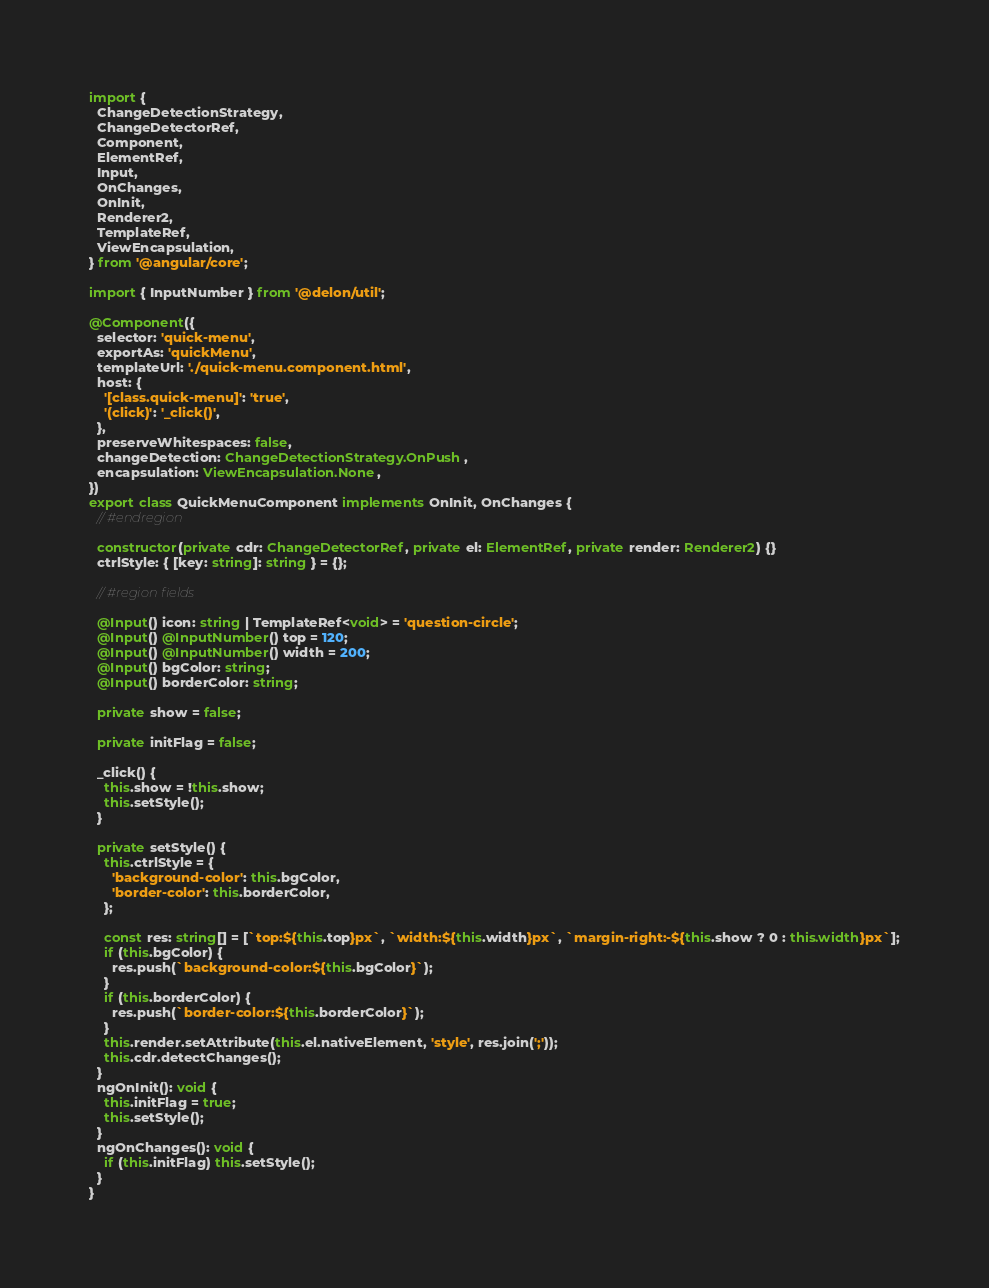Convert code to text. <code><loc_0><loc_0><loc_500><loc_500><_TypeScript_>import {
  ChangeDetectionStrategy,
  ChangeDetectorRef,
  Component,
  ElementRef,
  Input,
  OnChanges,
  OnInit,
  Renderer2,
  TemplateRef,
  ViewEncapsulation,
} from '@angular/core';

import { InputNumber } from '@delon/util';

@Component({
  selector: 'quick-menu',
  exportAs: 'quickMenu',
  templateUrl: './quick-menu.component.html',
  host: {
    '[class.quick-menu]': 'true',
    '(click)': '_click()',
  },
  preserveWhitespaces: false,
  changeDetection: ChangeDetectionStrategy.OnPush,
  encapsulation: ViewEncapsulation.None,
})
export class QuickMenuComponent implements OnInit, OnChanges {
  // #endregion

  constructor(private cdr: ChangeDetectorRef, private el: ElementRef, private render: Renderer2) {}
  ctrlStyle: { [key: string]: string } = {};

  // #region fields

  @Input() icon: string | TemplateRef<void> = 'question-circle';
  @Input() @InputNumber() top = 120;
  @Input() @InputNumber() width = 200;
  @Input() bgColor: string;
  @Input() borderColor: string;

  private show = false;

  private initFlag = false;

  _click() {
    this.show = !this.show;
    this.setStyle();
  }

  private setStyle() {
    this.ctrlStyle = {
      'background-color': this.bgColor,
      'border-color': this.borderColor,
    };

    const res: string[] = [`top:${this.top}px`, `width:${this.width}px`, `margin-right:-${this.show ? 0 : this.width}px`];
    if (this.bgColor) {
      res.push(`background-color:${this.bgColor}`);
    }
    if (this.borderColor) {
      res.push(`border-color:${this.borderColor}`);
    }
    this.render.setAttribute(this.el.nativeElement, 'style', res.join(';'));
    this.cdr.detectChanges();
  }
  ngOnInit(): void {
    this.initFlag = true;
    this.setStyle();
  }
  ngOnChanges(): void {
    if (this.initFlag) this.setStyle();
  }
}
</code> 